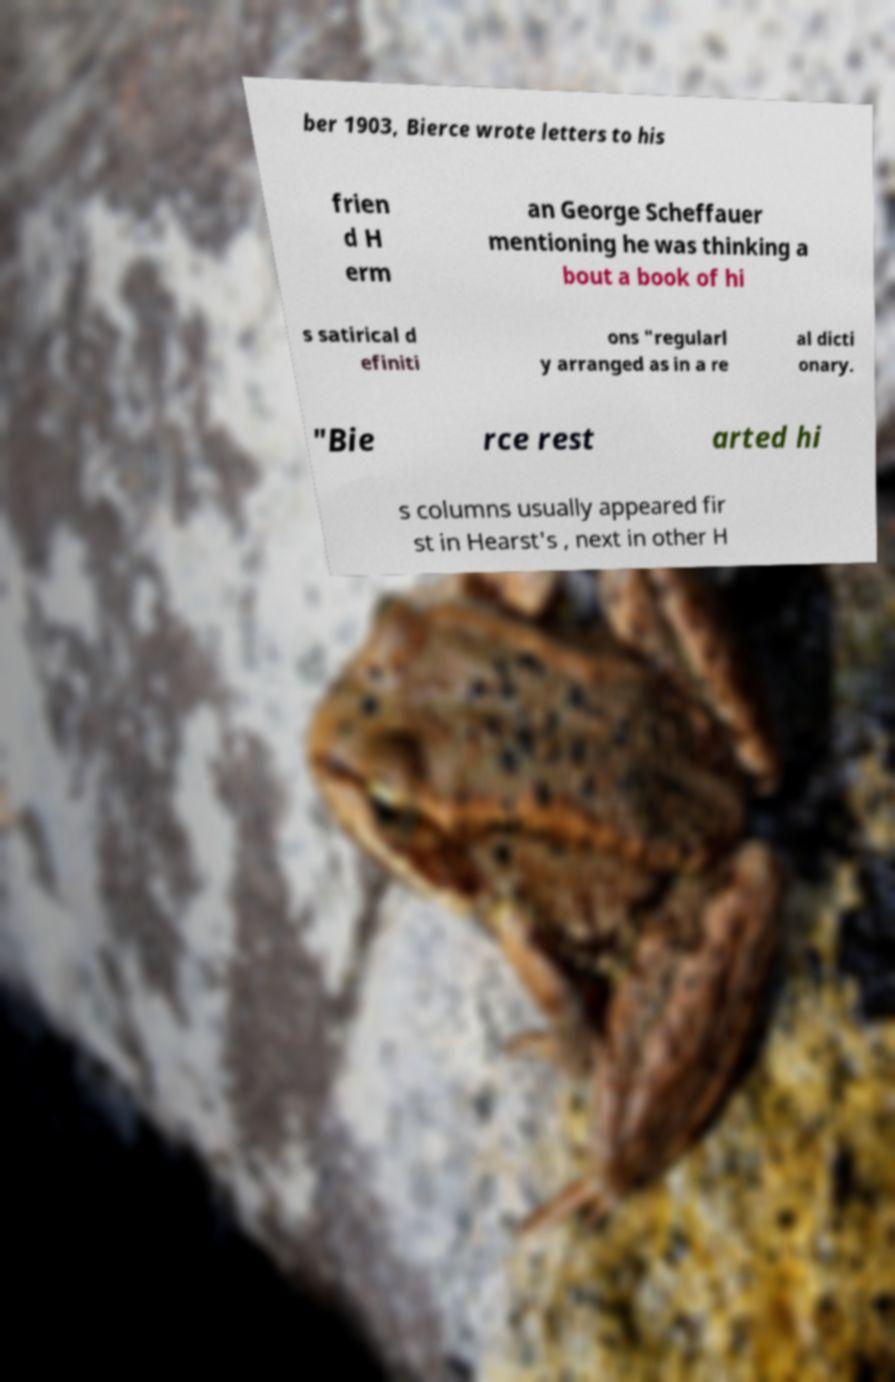What messages or text are displayed in this image? I need them in a readable, typed format. ber 1903, Bierce wrote letters to his frien d H erm an George Scheffauer mentioning he was thinking a bout a book of hi s satirical d efiniti ons "regularl y arranged as in a re al dicti onary. "Bie rce rest arted hi s columns usually appeared fir st in Hearst's , next in other H 